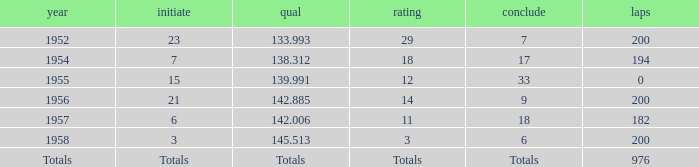What place did Jimmy Reece finish in 1957? 18.0. 